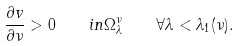<formula> <loc_0><loc_0><loc_500><loc_500>\frac { \partial v } { \partial \nu } > 0 \quad i n \Omega _ { \lambda } ^ { \nu } \quad \forall \lambda < \lambda _ { 1 } ( \nu ) .</formula> 